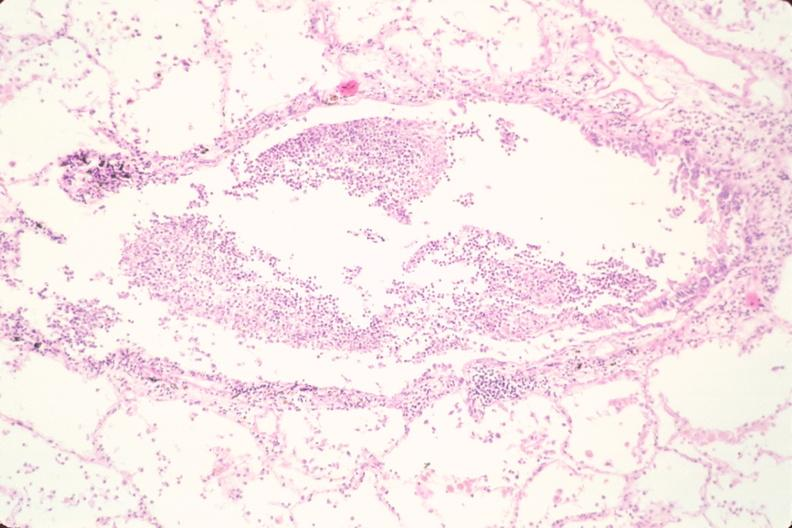what is present?
Answer the question using a single word or phrase. Respiratory 